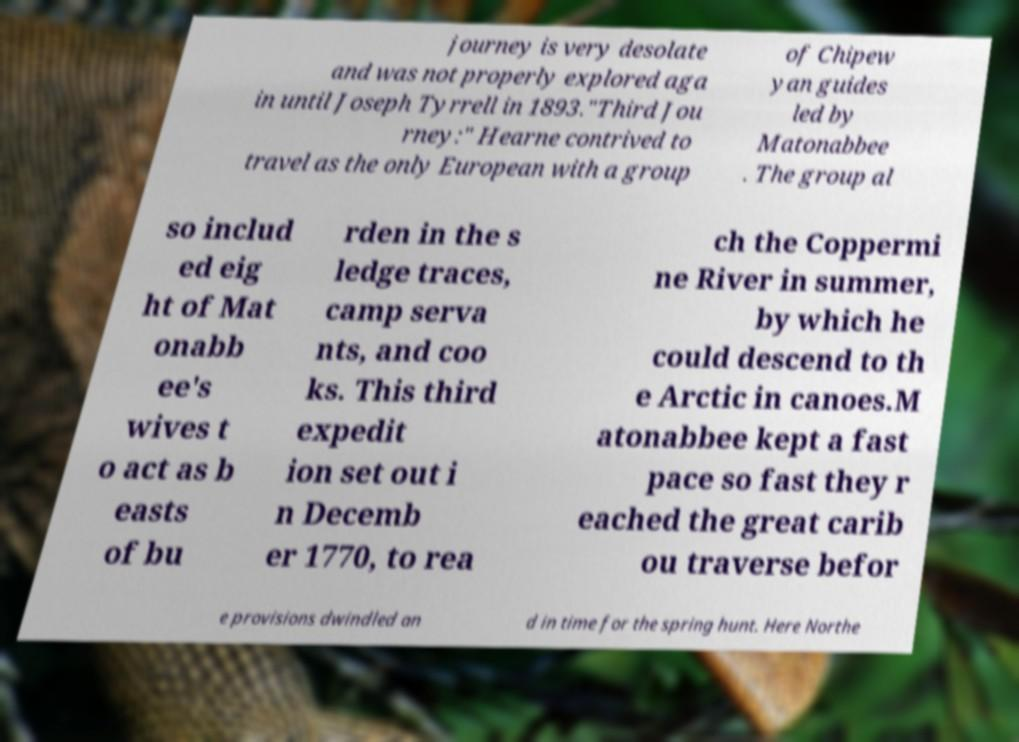I need the written content from this picture converted into text. Can you do that? journey is very desolate and was not properly explored aga in until Joseph Tyrrell in 1893."Third Jou rney:" Hearne contrived to travel as the only European with a group of Chipew yan guides led by Matonabbee . The group al so includ ed eig ht of Mat onabb ee's wives t o act as b easts of bu rden in the s ledge traces, camp serva nts, and coo ks. This third expedit ion set out i n Decemb er 1770, to rea ch the Coppermi ne River in summer, by which he could descend to th e Arctic in canoes.M atonabbee kept a fast pace so fast they r eached the great carib ou traverse befor e provisions dwindled an d in time for the spring hunt. Here Northe 